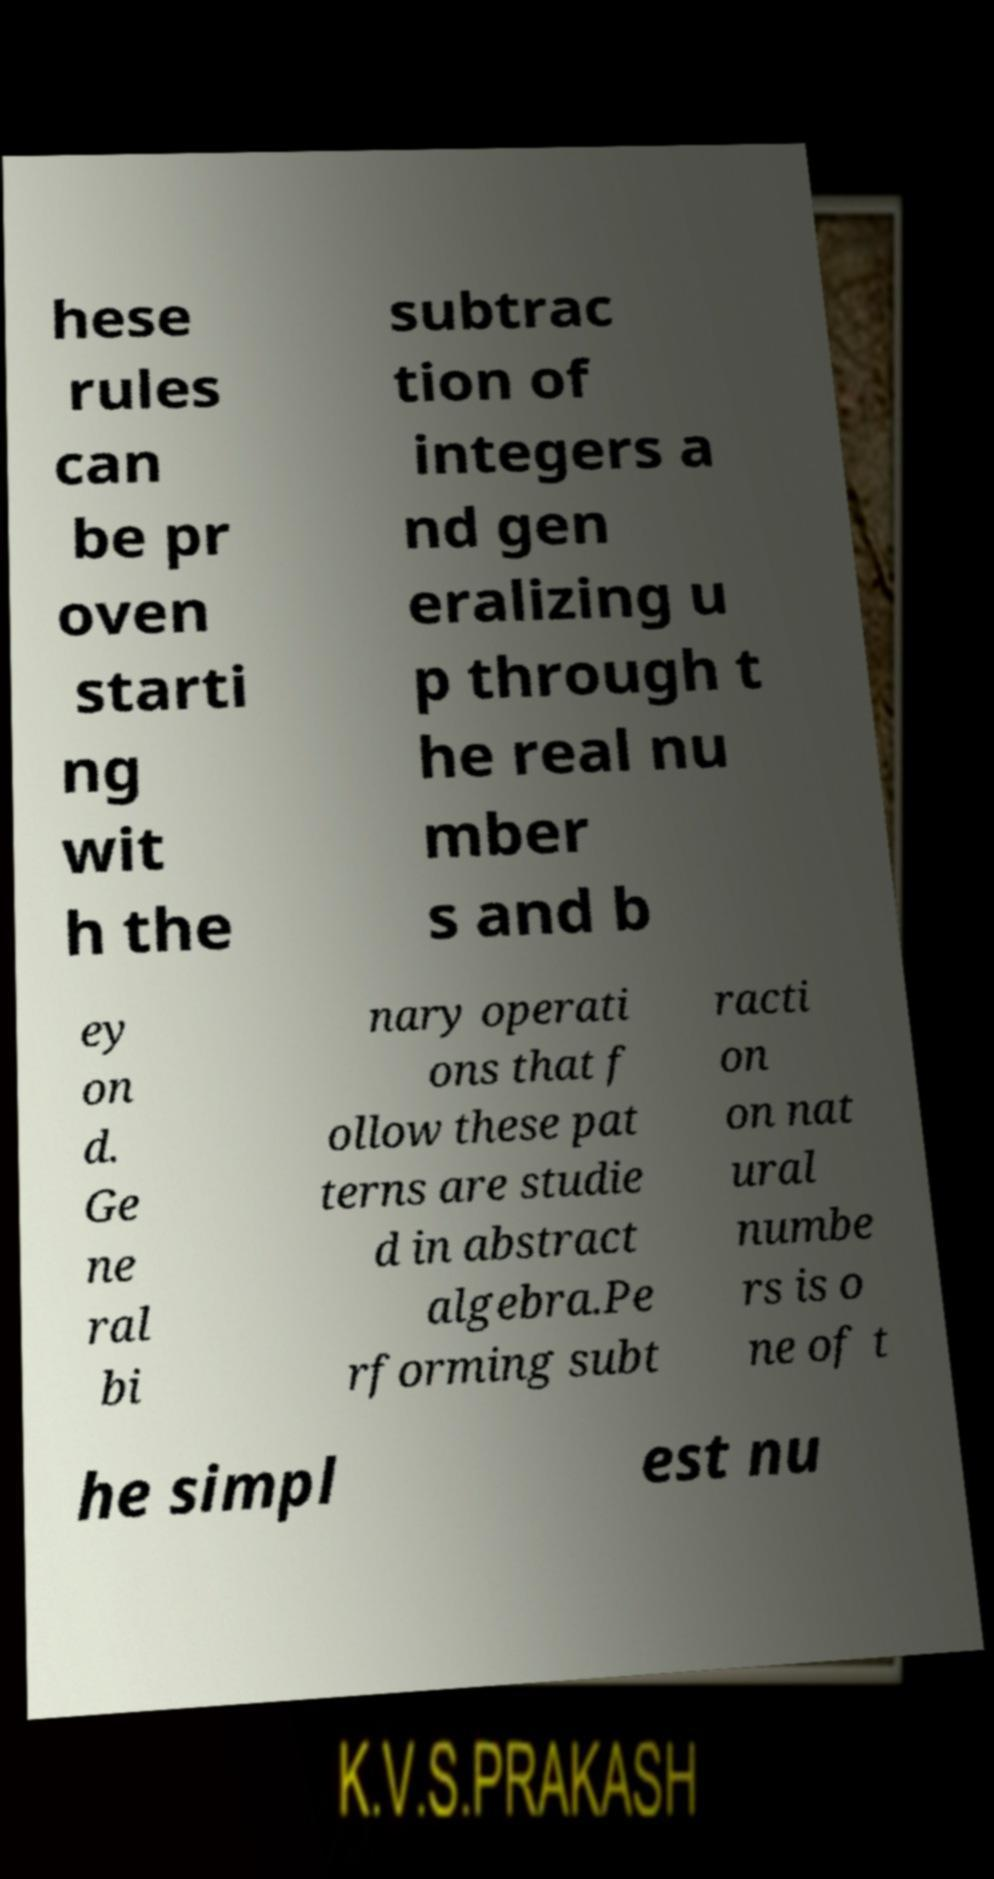Please read and relay the text visible in this image. What does it say? hese rules can be pr oven starti ng wit h the subtrac tion of integers a nd gen eralizing u p through t he real nu mber s and b ey on d. Ge ne ral bi nary operati ons that f ollow these pat terns are studie d in abstract algebra.Pe rforming subt racti on on nat ural numbe rs is o ne of t he simpl est nu 